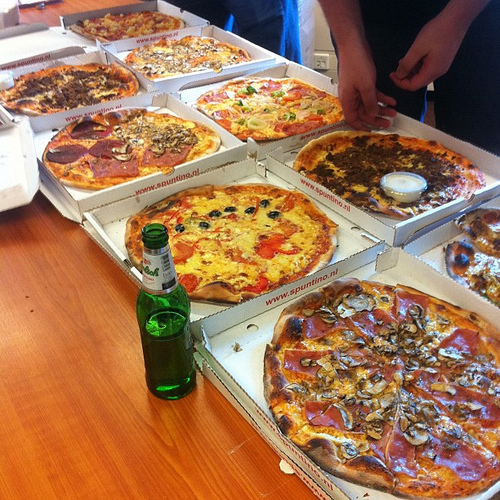Is there a fork to the left of the pizza with the pepper? No, there is no fork to the left of the pizza with the pepper. 